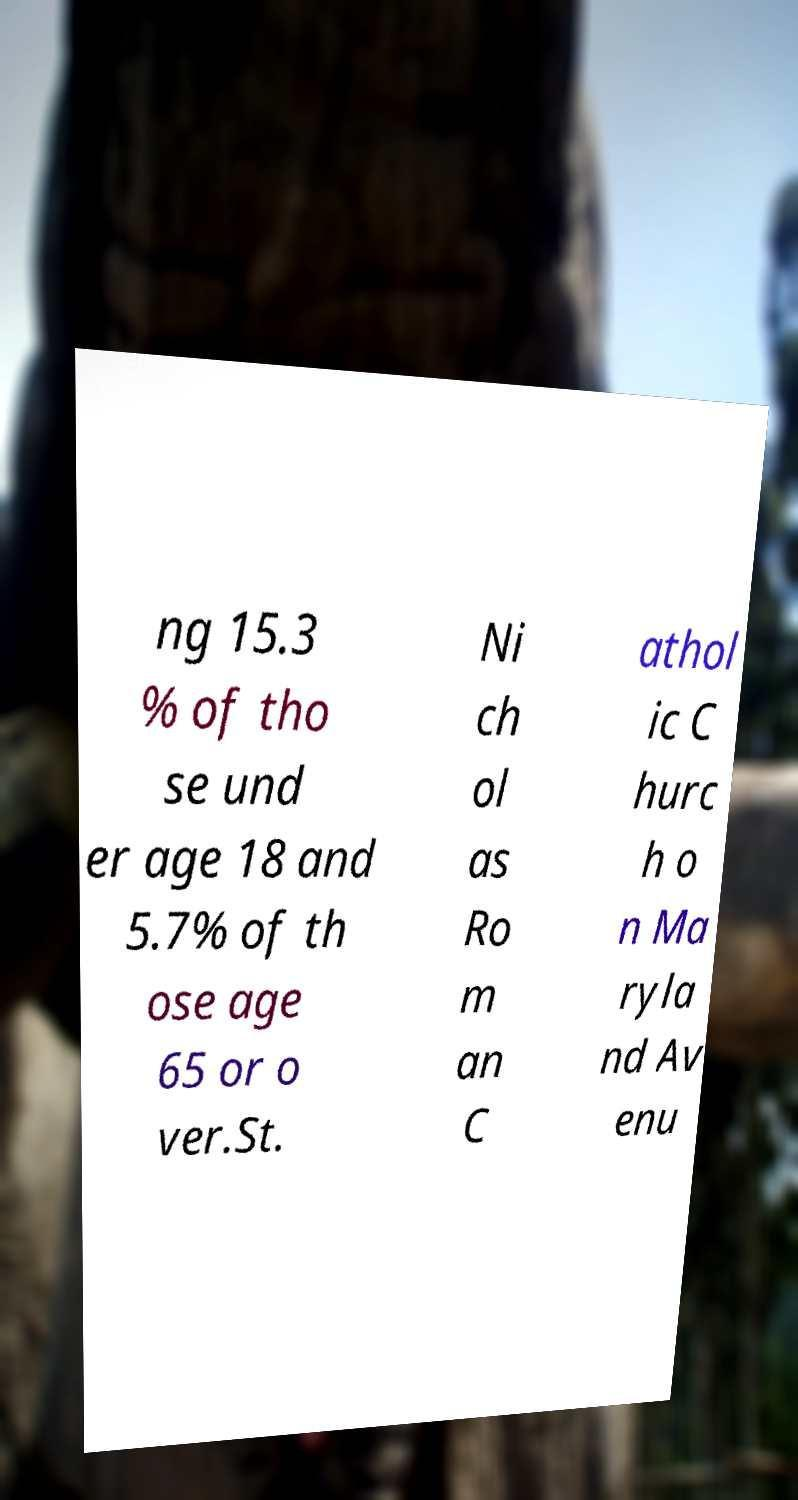Could you assist in decoding the text presented in this image and type it out clearly? ng 15.3 % of tho se und er age 18 and 5.7% of th ose age 65 or o ver.St. Ni ch ol as Ro m an C athol ic C hurc h o n Ma ryla nd Av enu 